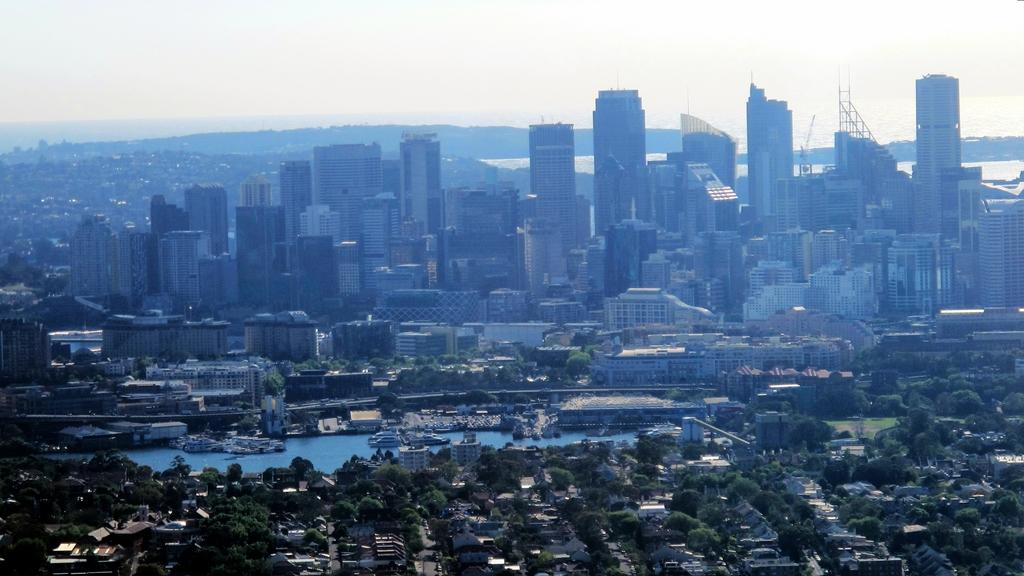What is the main subject of the image? The main subject of the image is an overview of a city. What types of structures can be seen in the image? There are buildings in the image. What other natural elements are present in the image? There are trees in the image. What mode of transportation can be seen on the water in the image? There are ships on the water in the image. What is visible at the top of the image? The sky is visible at the top of the image. What type of oatmeal is being served in the image? There is no oatmeal present in the image; it is an overview of a city with buildings, trees, ships, and the sky. How are the trucks being used in the image? There are no trucks present in the image; it features an overview of a city with buildings, trees, ships, and the sky. 